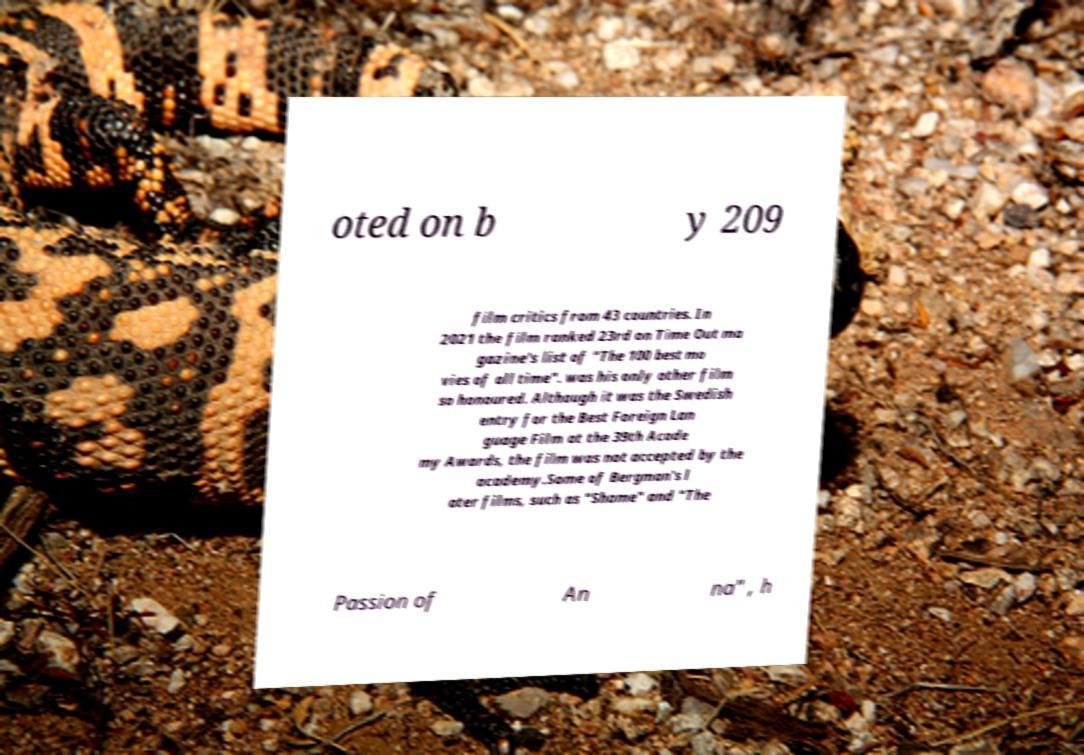Could you extract and type out the text from this image? oted on b y 209 film critics from 43 countries. In 2021 the film ranked 23rd on Time Out ma gazine's list of "The 100 best mo vies of all time". was his only other film so honoured. Although it was the Swedish entry for the Best Foreign Lan guage Film at the 39th Acade my Awards, the film was not accepted by the academy.Some of Bergman's l ater films, such as "Shame" and "The Passion of An na" , h 